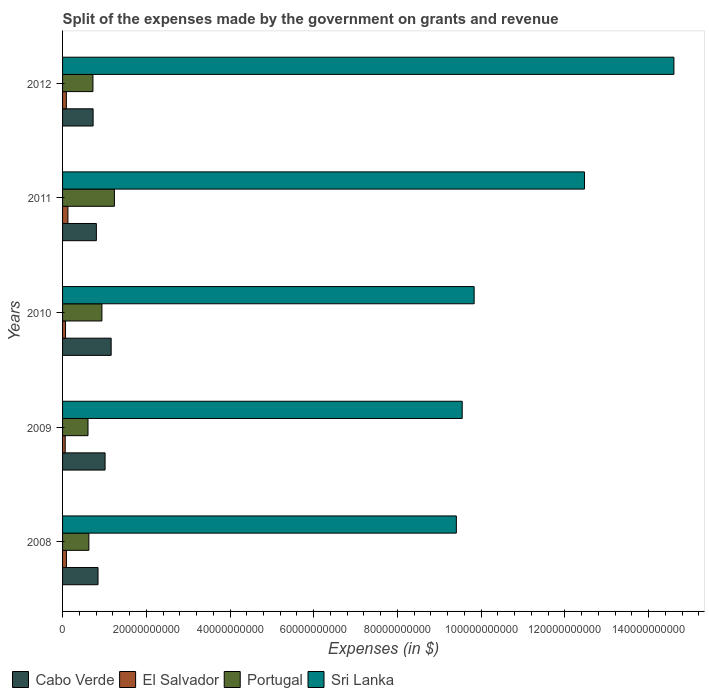How many groups of bars are there?
Keep it short and to the point. 5. Are the number of bars per tick equal to the number of legend labels?
Offer a very short reply. Yes. How many bars are there on the 5th tick from the top?
Your answer should be very brief. 4. What is the expenses made by the government on grants and revenue in Portugal in 2010?
Offer a terse response. 9.40e+09. Across all years, what is the maximum expenses made by the government on grants and revenue in Sri Lanka?
Your response must be concise. 1.46e+11. Across all years, what is the minimum expenses made by the government on grants and revenue in Portugal?
Your answer should be very brief. 6.08e+09. In which year was the expenses made by the government on grants and revenue in Portugal minimum?
Your response must be concise. 2009. What is the total expenses made by the government on grants and revenue in Portugal in the graph?
Keep it short and to the point. 4.14e+1. What is the difference between the expenses made by the government on grants and revenue in Sri Lanka in 2008 and that in 2012?
Provide a short and direct response. -5.20e+1. What is the difference between the expenses made by the government on grants and revenue in Cabo Verde in 2009 and the expenses made by the government on grants and revenue in Portugal in 2012?
Ensure brevity in your answer.  2.90e+09. What is the average expenses made by the government on grants and revenue in Portugal per year?
Provide a succinct answer. 8.28e+09. In the year 2012, what is the difference between the expenses made by the government on grants and revenue in Cabo Verde and expenses made by the government on grants and revenue in Sri Lanka?
Your answer should be compact. -1.39e+11. What is the ratio of the expenses made by the government on grants and revenue in El Salvador in 2009 to that in 2011?
Your answer should be compact. 0.5. Is the difference between the expenses made by the government on grants and revenue in Cabo Verde in 2010 and 2011 greater than the difference between the expenses made by the government on grants and revenue in Sri Lanka in 2010 and 2011?
Provide a succinct answer. Yes. What is the difference between the highest and the second highest expenses made by the government on grants and revenue in Portugal?
Your answer should be compact. 2.98e+09. What is the difference between the highest and the lowest expenses made by the government on grants and revenue in Portugal?
Give a very brief answer. 6.31e+09. In how many years, is the expenses made by the government on grants and revenue in Cabo Verde greater than the average expenses made by the government on grants and revenue in Cabo Verde taken over all years?
Your answer should be compact. 2. Is the sum of the expenses made by the government on grants and revenue in Cabo Verde in 2008 and 2009 greater than the maximum expenses made by the government on grants and revenue in El Salvador across all years?
Offer a very short reply. Yes. What does the 4th bar from the top in 2010 represents?
Provide a succinct answer. Cabo Verde. What does the 4th bar from the bottom in 2009 represents?
Offer a very short reply. Sri Lanka. Are all the bars in the graph horizontal?
Your answer should be compact. Yes. What is the difference between two consecutive major ticks on the X-axis?
Your answer should be compact. 2.00e+1. Are the values on the major ticks of X-axis written in scientific E-notation?
Give a very brief answer. No. Does the graph contain any zero values?
Your response must be concise. No. Does the graph contain grids?
Keep it short and to the point. No. Where does the legend appear in the graph?
Keep it short and to the point. Bottom left. How many legend labels are there?
Offer a very short reply. 4. How are the legend labels stacked?
Make the answer very short. Horizontal. What is the title of the graph?
Give a very brief answer. Split of the expenses made by the government on grants and revenue. What is the label or title of the X-axis?
Provide a short and direct response. Expenses (in $). What is the label or title of the Y-axis?
Keep it short and to the point. Years. What is the Expenses (in $) in Cabo Verde in 2008?
Offer a very short reply. 8.47e+09. What is the Expenses (in $) in El Salvador in 2008?
Offer a terse response. 9.26e+08. What is the Expenses (in $) in Portugal in 2008?
Provide a succinct answer. 6.28e+09. What is the Expenses (in $) in Sri Lanka in 2008?
Make the answer very short. 9.41e+1. What is the Expenses (in $) in Cabo Verde in 2009?
Your response must be concise. 1.02e+1. What is the Expenses (in $) in El Salvador in 2009?
Offer a very short reply. 6.34e+08. What is the Expenses (in $) in Portugal in 2009?
Offer a very short reply. 6.08e+09. What is the Expenses (in $) of Sri Lanka in 2009?
Provide a short and direct response. 9.55e+1. What is the Expenses (in $) of Cabo Verde in 2010?
Offer a very short reply. 1.16e+1. What is the Expenses (in $) of El Salvador in 2010?
Your answer should be compact. 7.09e+08. What is the Expenses (in $) in Portugal in 2010?
Ensure brevity in your answer.  9.40e+09. What is the Expenses (in $) in Sri Lanka in 2010?
Your response must be concise. 9.83e+1. What is the Expenses (in $) of Cabo Verde in 2011?
Keep it short and to the point. 8.08e+09. What is the Expenses (in $) in El Salvador in 2011?
Give a very brief answer. 1.28e+09. What is the Expenses (in $) in Portugal in 2011?
Ensure brevity in your answer.  1.24e+1. What is the Expenses (in $) of Sri Lanka in 2011?
Keep it short and to the point. 1.25e+11. What is the Expenses (in $) in Cabo Verde in 2012?
Ensure brevity in your answer.  7.30e+09. What is the Expenses (in $) in El Salvador in 2012?
Your answer should be very brief. 9.08e+08. What is the Expenses (in $) of Portugal in 2012?
Offer a very short reply. 7.26e+09. What is the Expenses (in $) of Sri Lanka in 2012?
Your answer should be compact. 1.46e+11. Across all years, what is the maximum Expenses (in $) in Cabo Verde?
Offer a terse response. 1.16e+1. Across all years, what is the maximum Expenses (in $) in El Salvador?
Offer a terse response. 1.28e+09. Across all years, what is the maximum Expenses (in $) in Portugal?
Keep it short and to the point. 1.24e+1. Across all years, what is the maximum Expenses (in $) in Sri Lanka?
Ensure brevity in your answer.  1.46e+11. Across all years, what is the minimum Expenses (in $) in Cabo Verde?
Make the answer very short. 7.30e+09. Across all years, what is the minimum Expenses (in $) of El Salvador?
Keep it short and to the point. 6.34e+08. Across all years, what is the minimum Expenses (in $) of Portugal?
Keep it short and to the point. 6.08e+09. Across all years, what is the minimum Expenses (in $) in Sri Lanka?
Your response must be concise. 9.41e+1. What is the total Expenses (in $) in Cabo Verde in the graph?
Ensure brevity in your answer.  4.56e+1. What is the total Expenses (in $) of El Salvador in the graph?
Provide a succinct answer. 4.46e+09. What is the total Expenses (in $) in Portugal in the graph?
Ensure brevity in your answer.  4.14e+1. What is the total Expenses (in $) of Sri Lanka in the graph?
Your answer should be compact. 5.59e+11. What is the difference between the Expenses (in $) of Cabo Verde in 2008 and that in 2009?
Your response must be concise. -1.68e+09. What is the difference between the Expenses (in $) in El Salvador in 2008 and that in 2009?
Your answer should be very brief. 2.92e+08. What is the difference between the Expenses (in $) in Portugal in 2008 and that in 2009?
Provide a short and direct response. 2.08e+08. What is the difference between the Expenses (in $) of Sri Lanka in 2008 and that in 2009?
Make the answer very short. -1.40e+09. What is the difference between the Expenses (in $) in Cabo Verde in 2008 and that in 2010?
Provide a short and direct response. -3.14e+09. What is the difference between the Expenses (in $) of El Salvador in 2008 and that in 2010?
Ensure brevity in your answer.  2.16e+08. What is the difference between the Expenses (in $) of Portugal in 2008 and that in 2010?
Give a very brief answer. -3.12e+09. What is the difference between the Expenses (in $) in Sri Lanka in 2008 and that in 2010?
Your answer should be very brief. -4.25e+09. What is the difference between the Expenses (in $) of Cabo Verde in 2008 and that in 2011?
Keep it short and to the point. 3.96e+08. What is the difference between the Expenses (in $) in El Salvador in 2008 and that in 2011?
Keep it short and to the point. -3.54e+08. What is the difference between the Expenses (in $) of Portugal in 2008 and that in 2011?
Give a very brief answer. -6.10e+09. What is the difference between the Expenses (in $) of Sri Lanka in 2008 and that in 2011?
Make the answer very short. -3.06e+1. What is the difference between the Expenses (in $) of Cabo Verde in 2008 and that in 2012?
Provide a succinct answer. 1.17e+09. What is the difference between the Expenses (in $) of El Salvador in 2008 and that in 2012?
Your answer should be compact. 1.77e+07. What is the difference between the Expenses (in $) of Portugal in 2008 and that in 2012?
Your response must be concise. -9.75e+08. What is the difference between the Expenses (in $) in Sri Lanka in 2008 and that in 2012?
Provide a short and direct response. -5.20e+1. What is the difference between the Expenses (in $) of Cabo Verde in 2009 and that in 2010?
Make the answer very short. -1.45e+09. What is the difference between the Expenses (in $) of El Salvador in 2009 and that in 2010?
Offer a terse response. -7.57e+07. What is the difference between the Expenses (in $) in Portugal in 2009 and that in 2010?
Your answer should be very brief. -3.33e+09. What is the difference between the Expenses (in $) of Sri Lanka in 2009 and that in 2010?
Your response must be concise. -2.85e+09. What is the difference between the Expenses (in $) in Cabo Verde in 2009 and that in 2011?
Keep it short and to the point. 2.08e+09. What is the difference between the Expenses (in $) of El Salvador in 2009 and that in 2011?
Provide a short and direct response. -6.46e+08. What is the difference between the Expenses (in $) of Portugal in 2009 and that in 2011?
Provide a short and direct response. -6.31e+09. What is the difference between the Expenses (in $) of Sri Lanka in 2009 and that in 2011?
Make the answer very short. -2.92e+1. What is the difference between the Expenses (in $) in Cabo Verde in 2009 and that in 2012?
Your answer should be very brief. 2.86e+09. What is the difference between the Expenses (in $) in El Salvador in 2009 and that in 2012?
Your answer should be compact. -2.74e+08. What is the difference between the Expenses (in $) of Portugal in 2009 and that in 2012?
Ensure brevity in your answer.  -1.18e+09. What is the difference between the Expenses (in $) of Sri Lanka in 2009 and that in 2012?
Give a very brief answer. -5.06e+1. What is the difference between the Expenses (in $) of Cabo Verde in 2010 and that in 2011?
Your answer should be compact. 3.53e+09. What is the difference between the Expenses (in $) in El Salvador in 2010 and that in 2011?
Your answer should be compact. -5.70e+08. What is the difference between the Expenses (in $) in Portugal in 2010 and that in 2011?
Your answer should be compact. -2.98e+09. What is the difference between the Expenses (in $) in Sri Lanka in 2010 and that in 2011?
Keep it short and to the point. -2.64e+1. What is the difference between the Expenses (in $) of Cabo Verde in 2010 and that in 2012?
Keep it short and to the point. 4.31e+09. What is the difference between the Expenses (in $) of El Salvador in 2010 and that in 2012?
Provide a succinct answer. -1.98e+08. What is the difference between the Expenses (in $) in Portugal in 2010 and that in 2012?
Keep it short and to the point. 2.14e+09. What is the difference between the Expenses (in $) of Sri Lanka in 2010 and that in 2012?
Provide a short and direct response. -4.77e+1. What is the difference between the Expenses (in $) of Cabo Verde in 2011 and that in 2012?
Make the answer very short. 7.79e+08. What is the difference between the Expenses (in $) in El Salvador in 2011 and that in 2012?
Make the answer very short. 3.72e+08. What is the difference between the Expenses (in $) in Portugal in 2011 and that in 2012?
Keep it short and to the point. 5.13e+09. What is the difference between the Expenses (in $) of Sri Lanka in 2011 and that in 2012?
Your answer should be compact. -2.14e+1. What is the difference between the Expenses (in $) of Cabo Verde in 2008 and the Expenses (in $) of El Salvador in 2009?
Provide a succinct answer. 7.84e+09. What is the difference between the Expenses (in $) of Cabo Verde in 2008 and the Expenses (in $) of Portugal in 2009?
Keep it short and to the point. 2.40e+09. What is the difference between the Expenses (in $) in Cabo Verde in 2008 and the Expenses (in $) in Sri Lanka in 2009?
Keep it short and to the point. -8.70e+1. What is the difference between the Expenses (in $) of El Salvador in 2008 and the Expenses (in $) of Portugal in 2009?
Keep it short and to the point. -5.15e+09. What is the difference between the Expenses (in $) in El Salvador in 2008 and the Expenses (in $) in Sri Lanka in 2009?
Keep it short and to the point. -9.45e+1. What is the difference between the Expenses (in $) of Portugal in 2008 and the Expenses (in $) of Sri Lanka in 2009?
Ensure brevity in your answer.  -8.92e+1. What is the difference between the Expenses (in $) of Cabo Verde in 2008 and the Expenses (in $) of El Salvador in 2010?
Make the answer very short. 7.76e+09. What is the difference between the Expenses (in $) of Cabo Verde in 2008 and the Expenses (in $) of Portugal in 2010?
Offer a very short reply. -9.29e+08. What is the difference between the Expenses (in $) of Cabo Verde in 2008 and the Expenses (in $) of Sri Lanka in 2010?
Give a very brief answer. -8.98e+1. What is the difference between the Expenses (in $) in El Salvador in 2008 and the Expenses (in $) in Portugal in 2010?
Keep it short and to the point. -8.48e+09. What is the difference between the Expenses (in $) in El Salvador in 2008 and the Expenses (in $) in Sri Lanka in 2010?
Offer a terse response. -9.74e+1. What is the difference between the Expenses (in $) in Portugal in 2008 and the Expenses (in $) in Sri Lanka in 2010?
Your answer should be compact. -9.20e+1. What is the difference between the Expenses (in $) in Cabo Verde in 2008 and the Expenses (in $) in El Salvador in 2011?
Give a very brief answer. 7.19e+09. What is the difference between the Expenses (in $) in Cabo Verde in 2008 and the Expenses (in $) in Portugal in 2011?
Give a very brief answer. -3.91e+09. What is the difference between the Expenses (in $) in Cabo Verde in 2008 and the Expenses (in $) in Sri Lanka in 2011?
Provide a succinct answer. -1.16e+11. What is the difference between the Expenses (in $) in El Salvador in 2008 and the Expenses (in $) in Portugal in 2011?
Offer a terse response. -1.15e+1. What is the difference between the Expenses (in $) in El Salvador in 2008 and the Expenses (in $) in Sri Lanka in 2011?
Your answer should be compact. -1.24e+11. What is the difference between the Expenses (in $) in Portugal in 2008 and the Expenses (in $) in Sri Lanka in 2011?
Your answer should be compact. -1.18e+11. What is the difference between the Expenses (in $) in Cabo Verde in 2008 and the Expenses (in $) in El Salvador in 2012?
Your answer should be compact. 7.56e+09. What is the difference between the Expenses (in $) in Cabo Verde in 2008 and the Expenses (in $) in Portugal in 2012?
Your response must be concise. 1.21e+09. What is the difference between the Expenses (in $) of Cabo Verde in 2008 and the Expenses (in $) of Sri Lanka in 2012?
Ensure brevity in your answer.  -1.38e+11. What is the difference between the Expenses (in $) of El Salvador in 2008 and the Expenses (in $) of Portugal in 2012?
Offer a terse response. -6.33e+09. What is the difference between the Expenses (in $) in El Salvador in 2008 and the Expenses (in $) in Sri Lanka in 2012?
Provide a succinct answer. -1.45e+11. What is the difference between the Expenses (in $) in Portugal in 2008 and the Expenses (in $) in Sri Lanka in 2012?
Provide a short and direct response. -1.40e+11. What is the difference between the Expenses (in $) of Cabo Verde in 2009 and the Expenses (in $) of El Salvador in 2010?
Provide a succinct answer. 9.44e+09. What is the difference between the Expenses (in $) in Cabo Verde in 2009 and the Expenses (in $) in Portugal in 2010?
Your answer should be very brief. 7.53e+08. What is the difference between the Expenses (in $) of Cabo Verde in 2009 and the Expenses (in $) of Sri Lanka in 2010?
Make the answer very short. -8.82e+1. What is the difference between the Expenses (in $) in El Salvador in 2009 and the Expenses (in $) in Portugal in 2010?
Make the answer very short. -8.77e+09. What is the difference between the Expenses (in $) of El Salvador in 2009 and the Expenses (in $) of Sri Lanka in 2010?
Your answer should be very brief. -9.77e+1. What is the difference between the Expenses (in $) in Portugal in 2009 and the Expenses (in $) in Sri Lanka in 2010?
Offer a very short reply. -9.22e+1. What is the difference between the Expenses (in $) of Cabo Verde in 2009 and the Expenses (in $) of El Salvador in 2011?
Make the answer very short. 8.87e+09. What is the difference between the Expenses (in $) in Cabo Verde in 2009 and the Expenses (in $) in Portugal in 2011?
Make the answer very short. -2.23e+09. What is the difference between the Expenses (in $) of Cabo Verde in 2009 and the Expenses (in $) of Sri Lanka in 2011?
Provide a short and direct response. -1.15e+11. What is the difference between the Expenses (in $) in El Salvador in 2009 and the Expenses (in $) in Portugal in 2011?
Provide a succinct answer. -1.18e+1. What is the difference between the Expenses (in $) in El Salvador in 2009 and the Expenses (in $) in Sri Lanka in 2011?
Offer a terse response. -1.24e+11. What is the difference between the Expenses (in $) of Portugal in 2009 and the Expenses (in $) of Sri Lanka in 2011?
Your answer should be compact. -1.19e+11. What is the difference between the Expenses (in $) of Cabo Verde in 2009 and the Expenses (in $) of El Salvador in 2012?
Offer a terse response. 9.25e+09. What is the difference between the Expenses (in $) in Cabo Verde in 2009 and the Expenses (in $) in Portugal in 2012?
Your response must be concise. 2.90e+09. What is the difference between the Expenses (in $) in Cabo Verde in 2009 and the Expenses (in $) in Sri Lanka in 2012?
Provide a succinct answer. -1.36e+11. What is the difference between the Expenses (in $) of El Salvador in 2009 and the Expenses (in $) of Portugal in 2012?
Provide a succinct answer. -6.62e+09. What is the difference between the Expenses (in $) in El Salvador in 2009 and the Expenses (in $) in Sri Lanka in 2012?
Offer a very short reply. -1.45e+11. What is the difference between the Expenses (in $) of Portugal in 2009 and the Expenses (in $) of Sri Lanka in 2012?
Give a very brief answer. -1.40e+11. What is the difference between the Expenses (in $) of Cabo Verde in 2010 and the Expenses (in $) of El Salvador in 2011?
Offer a very short reply. 1.03e+1. What is the difference between the Expenses (in $) of Cabo Verde in 2010 and the Expenses (in $) of Portugal in 2011?
Offer a terse response. -7.77e+08. What is the difference between the Expenses (in $) of Cabo Verde in 2010 and the Expenses (in $) of Sri Lanka in 2011?
Offer a very short reply. -1.13e+11. What is the difference between the Expenses (in $) of El Salvador in 2010 and the Expenses (in $) of Portugal in 2011?
Your answer should be very brief. -1.17e+1. What is the difference between the Expenses (in $) of El Salvador in 2010 and the Expenses (in $) of Sri Lanka in 2011?
Ensure brevity in your answer.  -1.24e+11. What is the difference between the Expenses (in $) in Portugal in 2010 and the Expenses (in $) in Sri Lanka in 2011?
Provide a succinct answer. -1.15e+11. What is the difference between the Expenses (in $) in Cabo Verde in 2010 and the Expenses (in $) in El Salvador in 2012?
Provide a succinct answer. 1.07e+1. What is the difference between the Expenses (in $) of Cabo Verde in 2010 and the Expenses (in $) of Portugal in 2012?
Your answer should be very brief. 4.35e+09. What is the difference between the Expenses (in $) of Cabo Verde in 2010 and the Expenses (in $) of Sri Lanka in 2012?
Make the answer very short. -1.34e+11. What is the difference between the Expenses (in $) of El Salvador in 2010 and the Expenses (in $) of Portugal in 2012?
Your response must be concise. -6.55e+09. What is the difference between the Expenses (in $) in El Salvador in 2010 and the Expenses (in $) in Sri Lanka in 2012?
Offer a terse response. -1.45e+11. What is the difference between the Expenses (in $) in Portugal in 2010 and the Expenses (in $) in Sri Lanka in 2012?
Your answer should be very brief. -1.37e+11. What is the difference between the Expenses (in $) of Cabo Verde in 2011 and the Expenses (in $) of El Salvador in 2012?
Ensure brevity in your answer.  7.17e+09. What is the difference between the Expenses (in $) of Cabo Verde in 2011 and the Expenses (in $) of Portugal in 2012?
Your response must be concise. 8.18e+08. What is the difference between the Expenses (in $) in Cabo Verde in 2011 and the Expenses (in $) in Sri Lanka in 2012?
Ensure brevity in your answer.  -1.38e+11. What is the difference between the Expenses (in $) in El Salvador in 2011 and the Expenses (in $) in Portugal in 2012?
Offer a very short reply. -5.98e+09. What is the difference between the Expenses (in $) of El Salvador in 2011 and the Expenses (in $) of Sri Lanka in 2012?
Your response must be concise. -1.45e+11. What is the difference between the Expenses (in $) in Portugal in 2011 and the Expenses (in $) in Sri Lanka in 2012?
Ensure brevity in your answer.  -1.34e+11. What is the average Expenses (in $) of Cabo Verde per year?
Your answer should be compact. 9.12e+09. What is the average Expenses (in $) of El Salvador per year?
Offer a terse response. 8.91e+08. What is the average Expenses (in $) of Portugal per year?
Your answer should be very brief. 8.28e+09. What is the average Expenses (in $) in Sri Lanka per year?
Offer a very short reply. 1.12e+11. In the year 2008, what is the difference between the Expenses (in $) of Cabo Verde and Expenses (in $) of El Salvador?
Ensure brevity in your answer.  7.55e+09. In the year 2008, what is the difference between the Expenses (in $) in Cabo Verde and Expenses (in $) in Portugal?
Provide a short and direct response. 2.19e+09. In the year 2008, what is the difference between the Expenses (in $) of Cabo Verde and Expenses (in $) of Sri Lanka?
Keep it short and to the point. -8.56e+1. In the year 2008, what is the difference between the Expenses (in $) in El Salvador and Expenses (in $) in Portugal?
Offer a very short reply. -5.36e+09. In the year 2008, what is the difference between the Expenses (in $) of El Salvador and Expenses (in $) of Sri Lanka?
Your response must be concise. -9.31e+1. In the year 2008, what is the difference between the Expenses (in $) in Portugal and Expenses (in $) in Sri Lanka?
Provide a short and direct response. -8.78e+1. In the year 2009, what is the difference between the Expenses (in $) of Cabo Verde and Expenses (in $) of El Salvador?
Ensure brevity in your answer.  9.52e+09. In the year 2009, what is the difference between the Expenses (in $) in Cabo Verde and Expenses (in $) in Portugal?
Offer a very short reply. 4.08e+09. In the year 2009, what is the difference between the Expenses (in $) of Cabo Verde and Expenses (in $) of Sri Lanka?
Your response must be concise. -8.53e+1. In the year 2009, what is the difference between the Expenses (in $) in El Salvador and Expenses (in $) in Portugal?
Provide a succinct answer. -5.44e+09. In the year 2009, what is the difference between the Expenses (in $) in El Salvador and Expenses (in $) in Sri Lanka?
Your answer should be compact. -9.48e+1. In the year 2009, what is the difference between the Expenses (in $) in Portugal and Expenses (in $) in Sri Lanka?
Provide a succinct answer. -8.94e+1. In the year 2010, what is the difference between the Expenses (in $) in Cabo Verde and Expenses (in $) in El Salvador?
Provide a short and direct response. 1.09e+1. In the year 2010, what is the difference between the Expenses (in $) of Cabo Verde and Expenses (in $) of Portugal?
Give a very brief answer. 2.21e+09. In the year 2010, what is the difference between the Expenses (in $) in Cabo Verde and Expenses (in $) in Sri Lanka?
Your answer should be very brief. -8.67e+1. In the year 2010, what is the difference between the Expenses (in $) in El Salvador and Expenses (in $) in Portugal?
Make the answer very short. -8.69e+09. In the year 2010, what is the difference between the Expenses (in $) of El Salvador and Expenses (in $) of Sri Lanka?
Give a very brief answer. -9.76e+1. In the year 2010, what is the difference between the Expenses (in $) in Portugal and Expenses (in $) in Sri Lanka?
Give a very brief answer. -8.89e+1. In the year 2011, what is the difference between the Expenses (in $) in Cabo Verde and Expenses (in $) in El Salvador?
Offer a very short reply. 6.80e+09. In the year 2011, what is the difference between the Expenses (in $) in Cabo Verde and Expenses (in $) in Portugal?
Give a very brief answer. -4.31e+09. In the year 2011, what is the difference between the Expenses (in $) of Cabo Verde and Expenses (in $) of Sri Lanka?
Give a very brief answer. -1.17e+11. In the year 2011, what is the difference between the Expenses (in $) of El Salvador and Expenses (in $) of Portugal?
Your response must be concise. -1.11e+1. In the year 2011, what is the difference between the Expenses (in $) in El Salvador and Expenses (in $) in Sri Lanka?
Keep it short and to the point. -1.23e+11. In the year 2011, what is the difference between the Expenses (in $) of Portugal and Expenses (in $) of Sri Lanka?
Give a very brief answer. -1.12e+11. In the year 2012, what is the difference between the Expenses (in $) of Cabo Verde and Expenses (in $) of El Salvador?
Make the answer very short. 6.39e+09. In the year 2012, what is the difference between the Expenses (in $) in Cabo Verde and Expenses (in $) in Portugal?
Provide a succinct answer. 3.89e+07. In the year 2012, what is the difference between the Expenses (in $) of Cabo Verde and Expenses (in $) of Sri Lanka?
Your response must be concise. -1.39e+11. In the year 2012, what is the difference between the Expenses (in $) in El Salvador and Expenses (in $) in Portugal?
Offer a very short reply. -6.35e+09. In the year 2012, what is the difference between the Expenses (in $) in El Salvador and Expenses (in $) in Sri Lanka?
Offer a very short reply. -1.45e+11. In the year 2012, what is the difference between the Expenses (in $) in Portugal and Expenses (in $) in Sri Lanka?
Provide a short and direct response. -1.39e+11. What is the ratio of the Expenses (in $) of Cabo Verde in 2008 to that in 2009?
Provide a succinct answer. 0.83. What is the ratio of the Expenses (in $) of El Salvador in 2008 to that in 2009?
Your response must be concise. 1.46. What is the ratio of the Expenses (in $) in Portugal in 2008 to that in 2009?
Your answer should be compact. 1.03. What is the ratio of the Expenses (in $) in Cabo Verde in 2008 to that in 2010?
Your answer should be compact. 0.73. What is the ratio of the Expenses (in $) in El Salvador in 2008 to that in 2010?
Your answer should be compact. 1.3. What is the ratio of the Expenses (in $) of Portugal in 2008 to that in 2010?
Give a very brief answer. 0.67. What is the ratio of the Expenses (in $) in Sri Lanka in 2008 to that in 2010?
Give a very brief answer. 0.96. What is the ratio of the Expenses (in $) of Cabo Verde in 2008 to that in 2011?
Give a very brief answer. 1.05. What is the ratio of the Expenses (in $) in El Salvador in 2008 to that in 2011?
Your answer should be compact. 0.72. What is the ratio of the Expenses (in $) of Portugal in 2008 to that in 2011?
Offer a terse response. 0.51. What is the ratio of the Expenses (in $) of Sri Lanka in 2008 to that in 2011?
Make the answer very short. 0.75. What is the ratio of the Expenses (in $) in Cabo Verde in 2008 to that in 2012?
Your answer should be compact. 1.16. What is the ratio of the Expenses (in $) in El Salvador in 2008 to that in 2012?
Provide a short and direct response. 1.02. What is the ratio of the Expenses (in $) in Portugal in 2008 to that in 2012?
Provide a succinct answer. 0.87. What is the ratio of the Expenses (in $) of Sri Lanka in 2008 to that in 2012?
Your answer should be compact. 0.64. What is the ratio of the Expenses (in $) in Cabo Verde in 2009 to that in 2010?
Keep it short and to the point. 0.87. What is the ratio of the Expenses (in $) of El Salvador in 2009 to that in 2010?
Offer a very short reply. 0.89. What is the ratio of the Expenses (in $) in Portugal in 2009 to that in 2010?
Ensure brevity in your answer.  0.65. What is the ratio of the Expenses (in $) of Sri Lanka in 2009 to that in 2010?
Offer a terse response. 0.97. What is the ratio of the Expenses (in $) of Cabo Verde in 2009 to that in 2011?
Provide a short and direct response. 1.26. What is the ratio of the Expenses (in $) in El Salvador in 2009 to that in 2011?
Provide a short and direct response. 0.5. What is the ratio of the Expenses (in $) in Portugal in 2009 to that in 2011?
Provide a short and direct response. 0.49. What is the ratio of the Expenses (in $) of Sri Lanka in 2009 to that in 2011?
Make the answer very short. 0.77. What is the ratio of the Expenses (in $) of Cabo Verde in 2009 to that in 2012?
Your response must be concise. 1.39. What is the ratio of the Expenses (in $) in El Salvador in 2009 to that in 2012?
Provide a succinct answer. 0.7. What is the ratio of the Expenses (in $) in Portugal in 2009 to that in 2012?
Your response must be concise. 0.84. What is the ratio of the Expenses (in $) of Sri Lanka in 2009 to that in 2012?
Your response must be concise. 0.65. What is the ratio of the Expenses (in $) in Cabo Verde in 2010 to that in 2011?
Your answer should be very brief. 1.44. What is the ratio of the Expenses (in $) in El Salvador in 2010 to that in 2011?
Offer a terse response. 0.55. What is the ratio of the Expenses (in $) of Portugal in 2010 to that in 2011?
Your response must be concise. 0.76. What is the ratio of the Expenses (in $) in Sri Lanka in 2010 to that in 2011?
Provide a succinct answer. 0.79. What is the ratio of the Expenses (in $) of Cabo Verde in 2010 to that in 2012?
Make the answer very short. 1.59. What is the ratio of the Expenses (in $) in El Salvador in 2010 to that in 2012?
Ensure brevity in your answer.  0.78. What is the ratio of the Expenses (in $) in Portugal in 2010 to that in 2012?
Your answer should be compact. 1.3. What is the ratio of the Expenses (in $) of Sri Lanka in 2010 to that in 2012?
Offer a very short reply. 0.67. What is the ratio of the Expenses (in $) in Cabo Verde in 2011 to that in 2012?
Offer a very short reply. 1.11. What is the ratio of the Expenses (in $) in El Salvador in 2011 to that in 2012?
Provide a short and direct response. 1.41. What is the ratio of the Expenses (in $) in Portugal in 2011 to that in 2012?
Your response must be concise. 1.71. What is the ratio of the Expenses (in $) in Sri Lanka in 2011 to that in 2012?
Ensure brevity in your answer.  0.85. What is the difference between the highest and the second highest Expenses (in $) in Cabo Verde?
Offer a terse response. 1.45e+09. What is the difference between the highest and the second highest Expenses (in $) of El Salvador?
Keep it short and to the point. 3.54e+08. What is the difference between the highest and the second highest Expenses (in $) of Portugal?
Make the answer very short. 2.98e+09. What is the difference between the highest and the second highest Expenses (in $) of Sri Lanka?
Keep it short and to the point. 2.14e+1. What is the difference between the highest and the lowest Expenses (in $) of Cabo Verde?
Your response must be concise. 4.31e+09. What is the difference between the highest and the lowest Expenses (in $) in El Salvador?
Provide a short and direct response. 6.46e+08. What is the difference between the highest and the lowest Expenses (in $) of Portugal?
Offer a terse response. 6.31e+09. What is the difference between the highest and the lowest Expenses (in $) in Sri Lanka?
Give a very brief answer. 5.20e+1. 